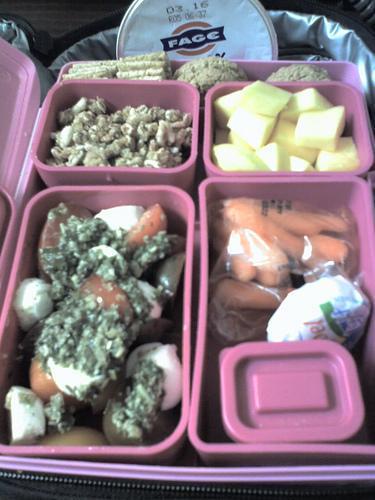How many purple containers still have lids on?
Give a very brief answer. 1. How many broccolis are in the picture?
Give a very brief answer. 3. How many apples are visible?
Give a very brief answer. 1. How many carrots can be seen?
Give a very brief answer. 2. 